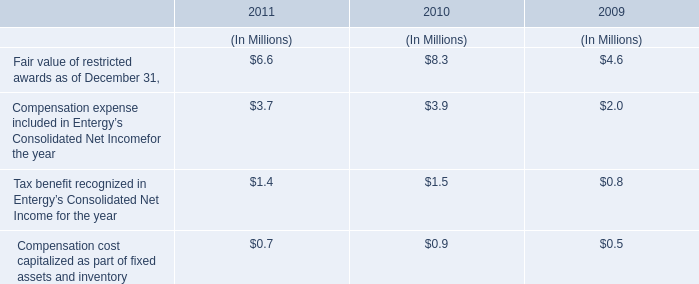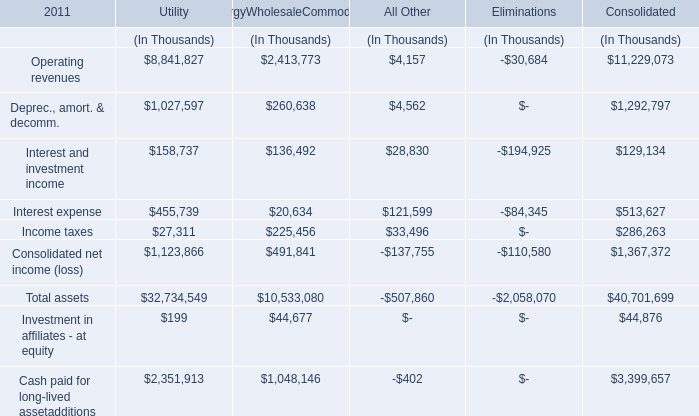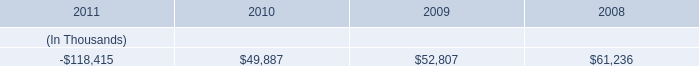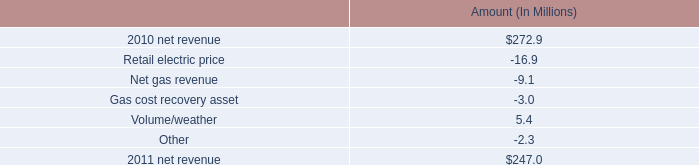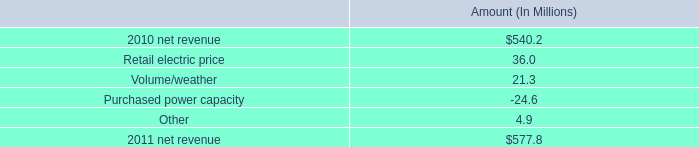what amount of credit facility was paid by entergy louisiana prior to december 31 , 2011 , ( in millions ) ? 
Computations: (200 - 50)
Answer: 150.0. 